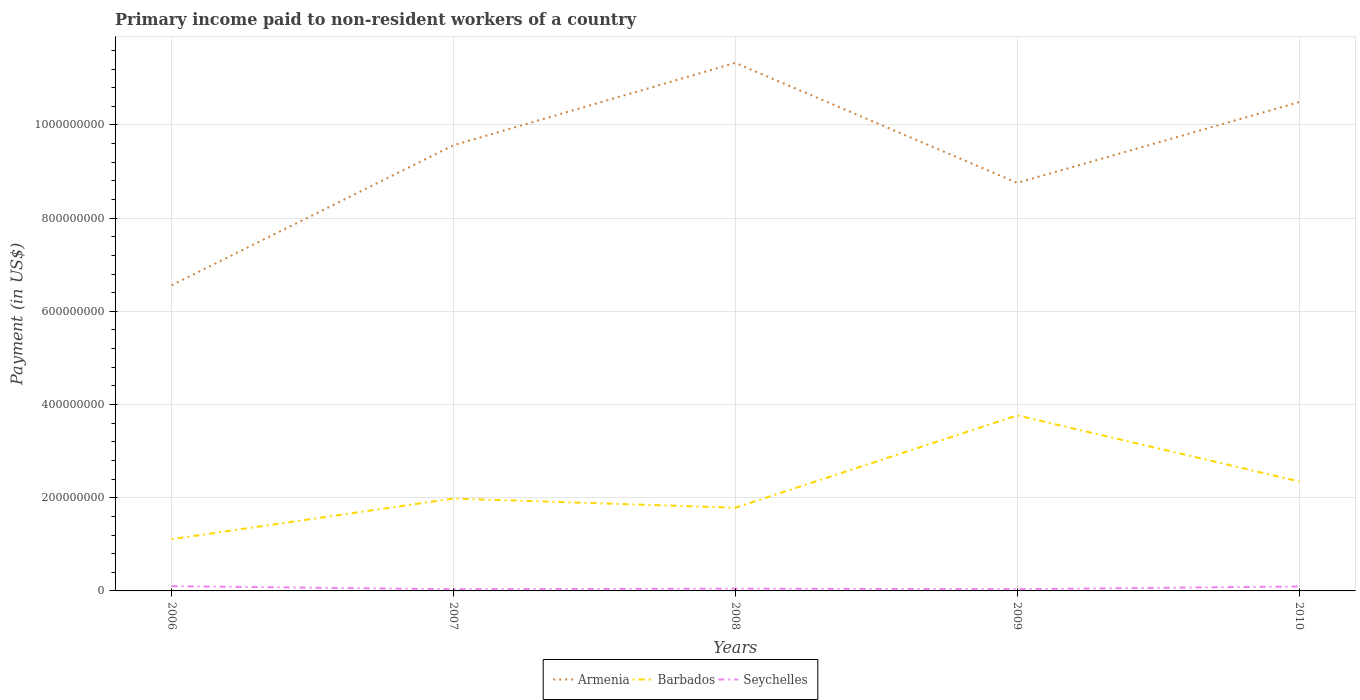How many different coloured lines are there?
Provide a short and direct response. 3. Is the number of lines equal to the number of legend labels?
Make the answer very short. Yes. Across all years, what is the maximum amount paid to workers in Seychelles?
Your response must be concise. 3.58e+06. In which year was the amount paid to workers in Seychelles maximum?
Your answer should be very brief. 2007. What is the total amount paid to workers in Armenia in the graph?
Keep it short and to the point. -1.73e+08. What is the difference between the highest and the second highest amount paid to workers in Seychelles?
Your response must be concise. 6.69e+06. What is the difference between the highest and the lowest amount paid to workers in Armenia?
Make the answer very short. 3. Is the amount paid to workers in Seychelles strictly greater than the amount paid to workers in Barbados over the years?
Offer a very short reply. Yes. What is the difference between two consecutive major ticks on the Y-axis?
Offer a terse response. 2.00e+08. What is the title of the graph?
Make the answer very short. Primary income paid to non-resident workers of a country. Does "Mongolia" appear as one of the legend labels in the graph?
Your answer should be very brief. No. What is the label or title of the X-axis?
Offer a very short reply. Years. What is the label or title of the Y-axis?
Ensure brevity in your answer.  Payment (in US$). What is the Payment (in US$) of Armenia in 2006?
Keep it short and to the point. 6.56e+08. What is the Payment (in US$) in Barbados in 2006?
Ensure brevity in your answer.  1.11e+08. What is the Payment (in US$) of Seychelles in 2006?
Provide a succinct answer. 1.03e+07. What is the Payment (in US$) of Armenia in 2007?
Offer a terse response. 9.56e+08. What is the Payment (in US$) of Barbados in 2007?
Offer a very short reply. 1.98e+08. What is the Payment (in US$) in Seychelles in 2007?
Keep it short and to the point. 3.58e+06. What is the Payment (in US$) in Armenia in 2008?
Keep it short and to the point. 1.13e+09. What is the Payment (in US$) in Barbados in 2008?
Make the answer very short. 1.79e+08. What is the Payment (in US$) in Seychelles in 2008?
Keep it short and to the point. 4.88e+06. What is the Payment (in US$) of Armenia in 2009?
Make the answer very short. 8.76e+08. What is the Payment (in US$) of Barbados in 2009?
Make the answer very short. 3.77e+08. What is the Payment (in US$) of Seychelles in 2009?
Give a very brief answer. 3.65e+06. What is the Payment (in US$) in Armenia in 2010?
Make the answer very short. 1.05e+09. What is the Payment (in US$) in Barbados in 2010?
Ensure brevity in your answer.  2.35e+08. What is the Payment (in US$) in Seychelles in 2010?
Offer a very short reply. 9.57e+06. Across all years, what is the maximum Payment (in US$) of Armenia?
Offer a very short reply. 1.13e+09. Across all years, what is the maximum Payment (in US$) in Barbados?
Make the answer very short. 3.77e+08. Across all years, what is the maximum Payment (in US$) in Seychelles?
Provide a succinct answer. 1.03e+07. Across all years, what is the minimum Payment (in US$) in Armenia?
Make the answer very short. 6.56e+08. Across all years, what is the minimum Payment (in US$) of Barbados?
Your answer should be compact. 1.11e+08. Across all years, what is the minimum Payment (in US$) of Seychelles?
Make the answer very short. 3.58e+06. What is the total Payment (in US$) of Armenia in the graph?
Keep it short and to the point. 4.67e+09. What is the total Payment (in US$) of Barbados in the graph?
Offer a terse response. 1.10e+09. What is the total Payment (in US$) in Seychelles in the graph?
Offer a very short reply. 3.19e+07. What is the difference between the Payment (in US$) in Armenia in 2006 and that in 2007?
Ensure brevity in your answer.  -3.00e+08. What is the difference between the Payment (in US$) in Barbados in 2006 and that in 2007?
Offer a very short reply. -8.72e+07. What is the difference between the Payment (in US$) in Seychelles in 2006 and that in 2007?
Give a very brief answer. 6.69e+06. What is the difference between the Payment (in US$) in Armenia in 2006 and that in 2008?
Keep it short and to the point. -4.77e+08. What is the difference between the Payment (in US$) in Barbados in 2006 and that in 2008?
Ensure brevity in your answer.  -6.75e+07. What is the difference between the Payment (in US$) of Seychelles in 2006 and that in 2008?
Keep it short and to the point. 5.39e+06. What is the difference between the Payment (in US$) of Armenia in 2006 and that in 2009?
Offer a terse response. -2.20e+08. What is the difference between the Payment (in US$) of Barbados in 2006 and that in 2009?
Make the answer very short. -2.66e+08. What is the difference between the Payment (in US$) in Seychelles in 2006 and that in 2009?
Ensure brevity in your answer.  6.62e+06. What is the difference between the Payment (in US$) of Armenia in 2006 and that in 2010?
Your answer should be compact. -3.93e+08. What is the difference between the Payment (in US$) of Barbados in 2006 and that in 2010?
Your answer should be compact. -1.24e+08. What is the difference between the Payment (in US$) of Seychelles in 2006 and that in 2010?
Provide a short and direct response. 6.96e+05. What is the difference between the Payment (in US$) of Armenia in 2007 and that in 2008?
Provide a succinct answer. -1.77e+08. What is the difference between the Payment (in US$) in Barbados in 2007 and that in 2008?
Keep it short and to the point. 1.97e+07. What is the difference between the Payment (in US$) of Seychelles in 2007 and that in 2008?
Make the answer very short. -1.31e+06. What is the difference between the Payment (in US$) in Armenia in 2007 and that in 2009?
Make the answer very short. 8.07e+07. What is the difference between the Payment (in US$) in Barbados in 2007 and that in 2009?
Give a very brief answer. -1.78e+08. What is the difference between the Payment (in US$) of Seychelles in 2007 and that in 2009?
Your answer should be very brief. -7.35e+04. What is the difference between the Payment (in US$) of Armenia in 2007 and that in 2010?
Ensure brevity in your answer.  -9.26e+07. What is the difference between the Payment (in US$) of Barbados in 2007 and that in 2010?
Offer a terse response. -3.68e+07. What is the difference between the Payment (in US$) in Seychelles in 2007 and that in 2010?
Give a very brief answer. -6.00e+06. What is the difference between the Payment (in US$) of Armenia in 2008 and that in 2009?
Give a very brief answer. 2.57e+08. What is the difference between the Payment (in US$) in Barbados in 2008 and that in 2009?
Provide a succinct answer. -1.98e+08. What is the difference between the Payment (in US$) in Seychelles in 2008 and that in 2009?
Your answer should be compact. 1.23e+06. What is the difference between the Payment (in US$) in Armenia in 2008 and that in 2010?
Provide a succinct answer. 8.42e+07. What is the difference between the Payment (in US$) in Barbados in 2008 and that in 2010?
Ensure brevity in your answer.  -5.65e+07. What is the difference between the Payment (in US$) in Seychelles in 2008 and that in 2010?
Provide a short and direct response. -4.69e+06. What is the difference between the Payment (in US$) in Armenia in 2009 and that in 2010?
Offer a very short reply. -1.73e+08. What is the difference between the Payment (in US$) in Barbados in 2009 and that in 2010?
Keep it short and to the point. 1.42e+08. What is the difference between the Payment (in US$) of Seychelles in 2009 and that in 2010?
Keep it short and to the point. -5.92e+06. What is the difference between the Payment (in US$) of Armenia in 2006 and the Payment (in US$) of Barbados in 2007?
Your answer should be compact. 4.58e+08. What is the difference between the Payment (in US$) in Armenia in 2006 and the Payment (in US$) in Seychelles in 2007?
Provide a short and direct response. 6.52e+08. What is the difference between the Payment (in US$) of Barbados in 2006 and the Payment (in US$) of Seychelles in 2007?
Ensure brevity in your answer.  1.07e+08. What is the difference between the Payment (in US$) in Armenia in 2006 and the Payment (in US$) in Barbados in 2008?
Keep it short and to the point. 4.77e+08. What is the difference between the Payment (in US$) of Armenia in 2006 and the Payment (in US$) of Seychelles in 2008?
Keep it short and to the point. 6.51e+08. What is the difference between the Payment (in US$) in Barbados in 2006 and the Payment (in US$) in Seychelles in 2008?
Provide a succinct answer. 1.06e+08. What is the difference between the Payment (in US$) of Armenia in 2006 and the Payment (in US$) of Barbados in 2009?
Ensure brevity in your answer.  2.79e+08. What is the difference between the Payment (in US$) in Armenia in 2006 and the Payment (in US$) in Seychelles in 2009?
Offer a very short reply. 6.52e+08. What is the difference between the Payment (in US$) in Barbados in 2006 and the Payment (in US$) in Seychelles in 2009?
Keep it short and to the point. 1.07e+08. What is the difference between the Payment (in US$) in Armenia in 2006 and the Payment (in US$) in Barbados in 2010?
Your answer should be compact. 4.21e+08. What is the difference between the Payment (in US$) in Armenia in 2006 and the Payment (in US$) in Seychelles in 2010?
Provide a short and direct response. 6.46e+08. What is the difference between the Payment (in US$) in Barbados in 2006 and the Payment (in US$) in Seychelles in 2010?
Your answer should be compact. 1.01e+08. What is the difference between the Payment (in US$) in Armenia in 2007 and the Payment (in US$) in Barbados in 2008?
Keep it short and to the point. 7.78e+08. What is the difference between the Payment (in US$) of Armenia in 2007 and the Payment (in US$) of Seychelles in 2008?
Your answer should be very brief. 9.52e+08. What is the difference between the Payment (in US$) of Barbados in 2007 and the Payment (in US$) of Seychelles in 2008?
Your response must be concise. 1.93e+08. What is the difference between the Payment (in US$) of Armenia in 2007 and the Payment (in US$) of Barbados in 2009?
Offer a very short reply. 5.80e+08. What is the difference between the Payment (in US$) in Armenia in 2007 and the Payment (in US$) in Seychelles in 2009?
Your answer should be very brief. 9.53e+08. What is the difference between the Payment (in US$) of Barbados in 2007 and the Payment (in US$) of Seychelles in 2009?
Your response must be concise. 1.95e+08. What is the difference between the Payment (in US$) of Armenia in 2007 and the Payment (in US$) of Barbados in 2010?
Provide a short and direct response. 7.21e+08. What is the difference between the Payment (in US$) of Armenia in 2007 and the Payment (in US$) of Seychelles in 2010?
Offer a very short reply. 9.47e+08. What is the difference between the Payment (in US$) of Barbados in 2007 and the Payment (in US$) of Seychelles in 2010?
Provide a short and direct response. 1.89e+08. What is the difference between the Payment (in US$) of Armenia in 2008 and the Payment (in US$) of Barbados in 2009?
Make the answer very short. 7.57e+08. What is the difference between the Payment (in US$) of Armenia in 2008 and the Payment (in US$) of Seychelles in 2009?
Make the answer very short. 1.13e+09. What is the difference between the Payment (in US$) in Barbados in 2008 and the Payment (in US$) in Seychelles in 2009?
Your answer should be compact. 1.75e+08. What is the difference between the Payment (in US$) of Armenia in 2008 and the Payment (in US$) of Barbados in 2010?
Offer a terse response. 8.98e+08. What is the difference between the Payment (in US$) in Armenia in 2008 and the Payment (in US$) in Seychelles in 2010?
Your answer should be compact. 1.12e+09. What is the difference between the Payment (in US$) of Barbados in 2008 and the Payment (in US$) of Seychelles in 2010?
Provide a succinct answer. 1.69e+08. What is the difference between the Payment (in US$) of Armenia in 2009 and the Payment (in US$) of Barbados in 2010?
Provide a short and direct response. 6.41e+08. What is the difference between the Payment (in US$) in Armenia in 2009 and the Payment (in US$) in Seychelles in 2010?
Offer a very short reply. 8.66e+08. What is the difference between the Payment (in US$) of Barbados in 2009 and the Payment (in US$) of Seychelles in 2010?
Provide a short and direct response. 3.67e+08. What is the average Payment (in US$) in Armenia per year?
Provide a short and direct response. 9.34e+08. What is the average Payment (in US$) in Barbados per year?
Make the answer very short. 2.20e+08. What is the average Payment (in US$) in Seychelles per year?
Your response must be concise. 6.39e+06. In the year 2006, what is the difference between the Payment (in US$) of Armenia and Payment (in US$) of Barbados?
Offer a terse response. 5.45e+08. In the year 2006, what is the difference between the Payment (in US$) of Armenia and Payment (in US$) of Seychelles?
Your answer should be compact. 6.46e+08. In the year 2006, what is the difference between the Payment (in US$) of Barbados and Payment (in US$) of Seychelles?
Your answer should be very brief. 1.01e+08. In the year 2007, what is the difference between the Payment (in US$) in Armenia and Payment (in US$) in Barbados?
Provide a succinct answer. 7.58e+08. In the year 2007, what is the difference between the Payment (in US$) in Armenia and Payment (in US$) in Seychelles?
Your answer should be very brief. 9.53e+08. In the year 2007, what is the difference between the Payment (in US$) in Barbados and Payment (in US$) in Seychelles?
Offer a terse response. 1.95e+08. In the year 2008, what is the difference between the Payment (in US$) in Armenia and Payment (in US$) in Barbados?
Your response must be concise. 9.55e+08. In the year 2008, what is the difference between the Payment (in US$) of Armenia and Payment (in US$) of Seychelles?
Your response must be concise. 1.13e+09. In the year 2008, what is the difference between the Payment (in US$) in Barbados and Payment (in US$) in Seychelles?
Provide a short and direct response. 1.74e+08. In the year 2009, what is the difference between the Payment (in US$) of Armenia and Payment (in US$) of Barbados?
Ensure brevity in your answer.  4.99e+08. In the year 2009, what is the difference between the Payment (in US$) in Armenia and Payment (in US$) in Seychelles?
Offer a terse response. 8.72e+08. In the year 2009, what is the difference between the Payment (in US$) in Barbados and Payment (in US$) in Seychelles?
Your response must be concise. 3.73e+08. In the year 2010, what is the difference between the Payment (in US$) in Armenia and Payment (in US$) in Barbados?
Your response must be concise. 8.14e+08. In the year 2010, what is the difference between the Payment (in US$) in Armenia and Payment (in US$) in Seychelles?
Give a very brief answer. 1.04e+09. In the year 2010, what is the difference between the Payment (in US$) in Barbados and Payment (in US$) in Seychelles?
Offer a terse response. 2.25e+08. What is the ratio of the Payment (in US$) of Armenia in 2006 to that in 2007?
Provide a succinct answer. 0.69. What is the ratio of the Payment (in US$) in Barbados in 2006 to that in 2007?
Ensure brevity in your answer.  0.56. What is the ratio of the Payment (in US$) in Seychelles in 2006 to that in 2007?
Make the answer very short. 2.87. What is the ratio of the Payment (in US$) in Armenia in 2006 to that in 2008?
Provide a succinct answer. 0.58. What is the ratio of the Payment (in US$) of Barbados in 2006 to that in 2008?
Offer a very short reply. 0.62. What is the ratio of the Payment (in US$) of Seychelles in 2006 to that in 2008?
Your response must be concise. 2.1. What is the ratio of the Payment (in US$) in Armenia in 2006 to that in 2009?
Offer a terse response. 0.75. What is the ratio of the Payment (in US$) of Barbados in 2006 to that in 2009?
Make the answer very short. 0.29. What is the ratio of the Payment (in US$) of Seychelles in 2006 to that in 2009?
Your answer should be compact. 2.81. What is the ratio of the Payment (in US$) of Armenia in 2006 to that in 2010?
Provide a succinct answer. 0.63. What is the ratio of the Payment (in US$) of Barbados in 2006 to that in 2010?
Provide a short and direct response. 0.47. What is the ratio of the Payment (in US$) of Seychelles in 2006 to that in 2010?
Ensure brevity in your answer.  1.07. What is the ratio of the Payment (in US$) of Armenia in 2007 to that in 2008?
Provide a short and direct response. 0.84. What is the ratio of the Payment (in US$) in Barbados in 2007 to that in 2008?
Provide a succinct answer. 1.11. What is the ratio of the Payment (in US$) in Seychelles in 2007 to that in 2008?
Make the answer very short. 0.73. What is the ratio of the Payment (in US$) of Armenia in 2007 to that in 2009?
Keep it short and to the point. 1.09. What is the ratio of the Payment (in US$) in Barbados in 2007 to that in 2009?
Your answer should be very brief. 0.53. What is the ratio of the Payment (in US$) of Seychelles in 2007 to that in 2009?
Provide a short and direct response. 0.98. What is the ratio of the Payment (in US$) in Armenia in 2007 to that in 2010?
Make the answer very short. 0.91. What is the ratio of the Payment (in US$) of Barbados in 2007 to that in 2010?
Keep it short and to the point. 0.84. What is the ratio of the Payment (in US$) in Seychelles in 2007 to that in 2010?
Provide a succinct answer. 0.37. What is the ratio of the Payment (in US$) of Armenia in 2008 to that in 2009?
Your answer should be very brief. 1.29. What is the ratio of the Payment (in US$) in Barbados in 2008 to that in 2009?
Keep it short and to the point. 0.47. What is the ratio of the Payment (in US$) of Seychelles in 2008 to that in 2009?
Make the answer very short. 1.34. What is the ratio of the Payment (in US$) of Armenia in 2008 to that in 2010?
Make the answer very short. 1.08. What is the ratio of the Payment (in US$) in Barbados in 2008 to that in 2010?
Give a very brief answer. 0.76. What is the ratio of the Payment (in US$) of Seychelles in 2008 to that in 2010?
Keep it short and to the point. 0.51. What is the ratio of the Payment (in US$) of Armenia in 2009 to that in 2010?
Give a very brief answer. 0.83. What is the ratio of the Payment (in US$) in Barbados in 2009 to that in 2010?
Your response must be concise. 1.6. What is the ratio of the Payment (in US$) in Seychelles in 2009 to that in 2010?
Offer a terse response. 0.38. What is the difference between the highest and the second highest Payment (in US$) of Armenia?
Give a very brief answer. 8.42e+07. What is the difference between the highest and the second highest Payment (in US$) in Barbados?
Offer a terse response. 1.42e+08. What is the difference between the highest and the second highest Payment (in US$) in Seychelles?
Make the answer very short. 6.96e+05. What is the difference between the highest and the lowest Payment (in US$) of Armenia?
Ensure brevity in your answer.  4.77e+08. What is the difference between the highest and the lowest Payment (in US$) in Barbados?
Offer a terse response. 2.66e+08. What is the difference between the highest and the lowest Payment (in US$) in Seychelles?
Your response must be concise. 6.69e+06. 